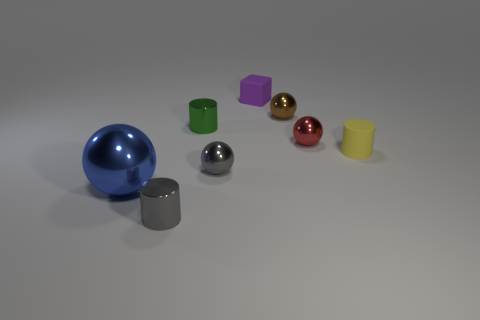Do the green thing and the cube have the same size?
Provide a short and direct response. Yes. Are there any other things that are the same shape as the purple thing?
Make the answer very short. No. Do the yellow object and the cylinder in front of the big blue object have the same material?
Give a very brief answer. No. How many spheres are both left of the red metal thing and behind the large blue metallic object?
Your answer should be very brief. 2. What number of other things are there of the same material as the red ball
Offer a very short reply. 5. Are the cylinder in front of the gray ball and the blue sphere made of the same material?
Ensure brevity in your answer.  Yes. What is the size of the metallic sphere to the left of the tiny shiny cylinder that is behind the small metallic sphere that is to the left of the small matte cube?
Your answer should be compact. Large. What number of other objects are the same color as the big metal thing?
Offer a very short reply. 0. What is the shape of the brown object that is the same size as the gray metal cylinder?
Provide a short and direct response. Sphere. There is a object behind the small brown metal sphere; how big is it?
Ensure brevity in your answer.  Small. 